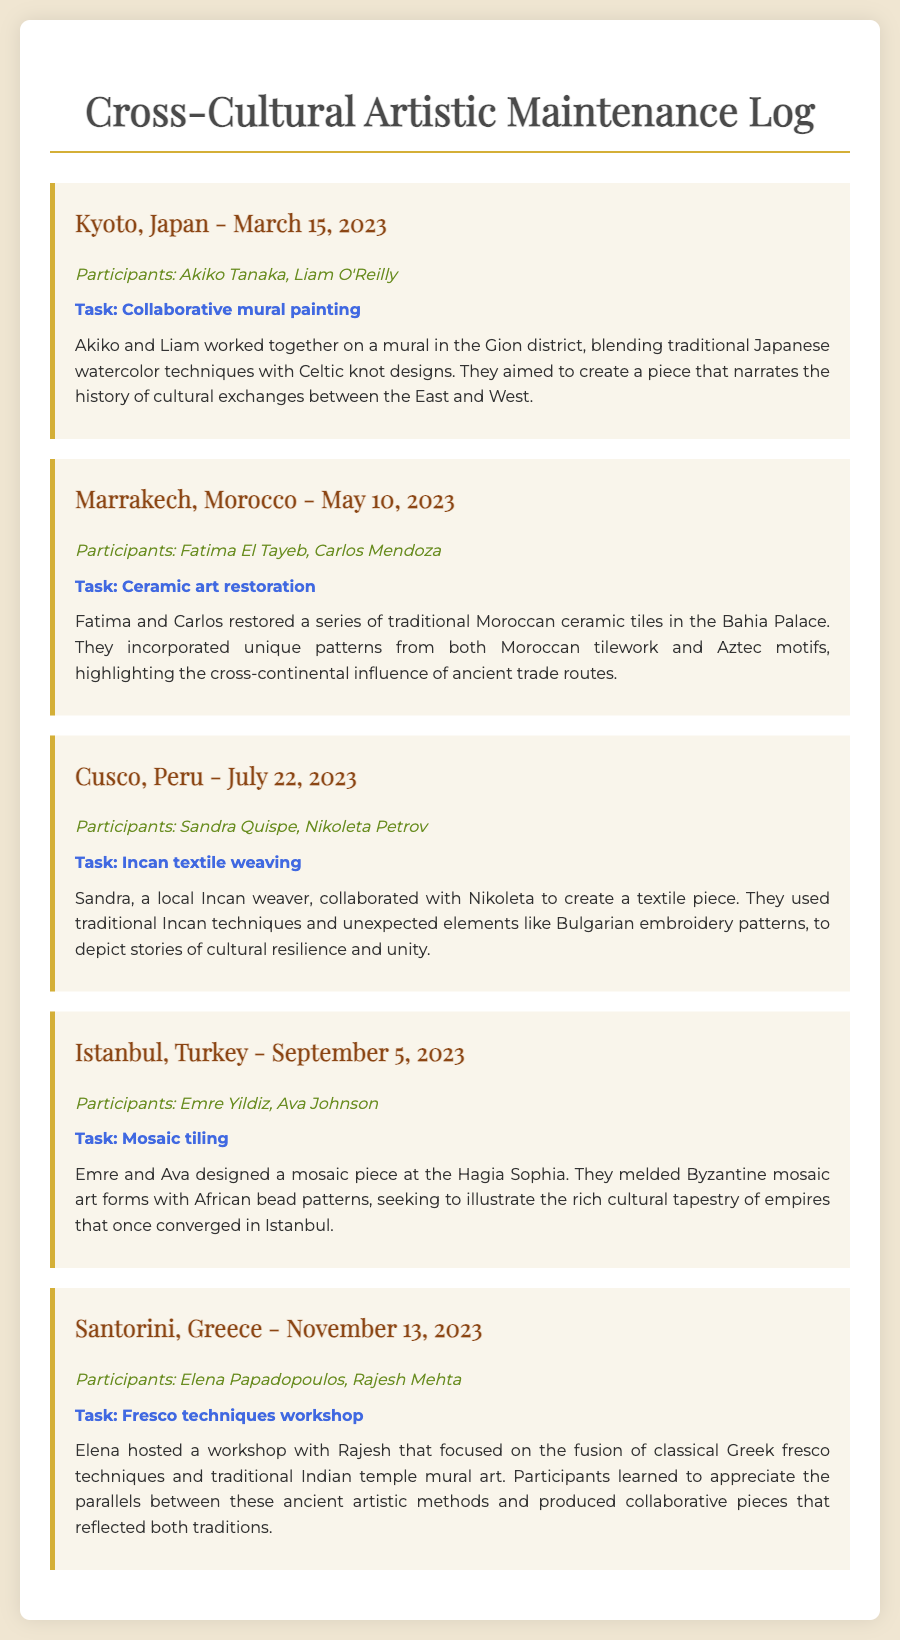What is the location of the mural painting task? The location of the mural painting task is mentioned as Kyoto, Japan.
Answer: Kyoto, Japan Who are the participants in the ceramic art restoration? The participants in the ceramic art restoration are Fatima El Tayeb and Carlos Mendoza.
Answer: Fatima El Tayeb, Carlos Mendoza What is the date of the Incan textile weaving task? The date of the Incan textile weaving task is July 22, 2023.
Answer: July 22, 2023 What artistic techniques were blended in the fresco techniques workshop? The workshop blended classical Greek fresco techniques and traditional Indian temple mural art.
Answer: Classical Greek fresco techniques and traditional Indian temple mural art Which city hosted a mosaic tiling task? The city that hosted a mosaic tiling task is Istanbul.
Answer: Istanbul What cultural influences were highlighted in the ceramic art restoration? The cultural influences highlighted were Moroccan tilework and Aztec motifs.
Answer: Moroccan tilework and Aztec motifs How many log entries are documented in total? The total number of log entries documented is five.
Answer: Five What was the focus of the workshop hosted by Elena? The focus of the workshop was on the fusion of classical Greek fresco techniques and traditional Indian temple mural art.
Answer: Fusion of classical Greek fresco techniques and traditional Indian temple mural art In what district was the mural created? The mural was created in the Gion district.
Answer: Gion district 